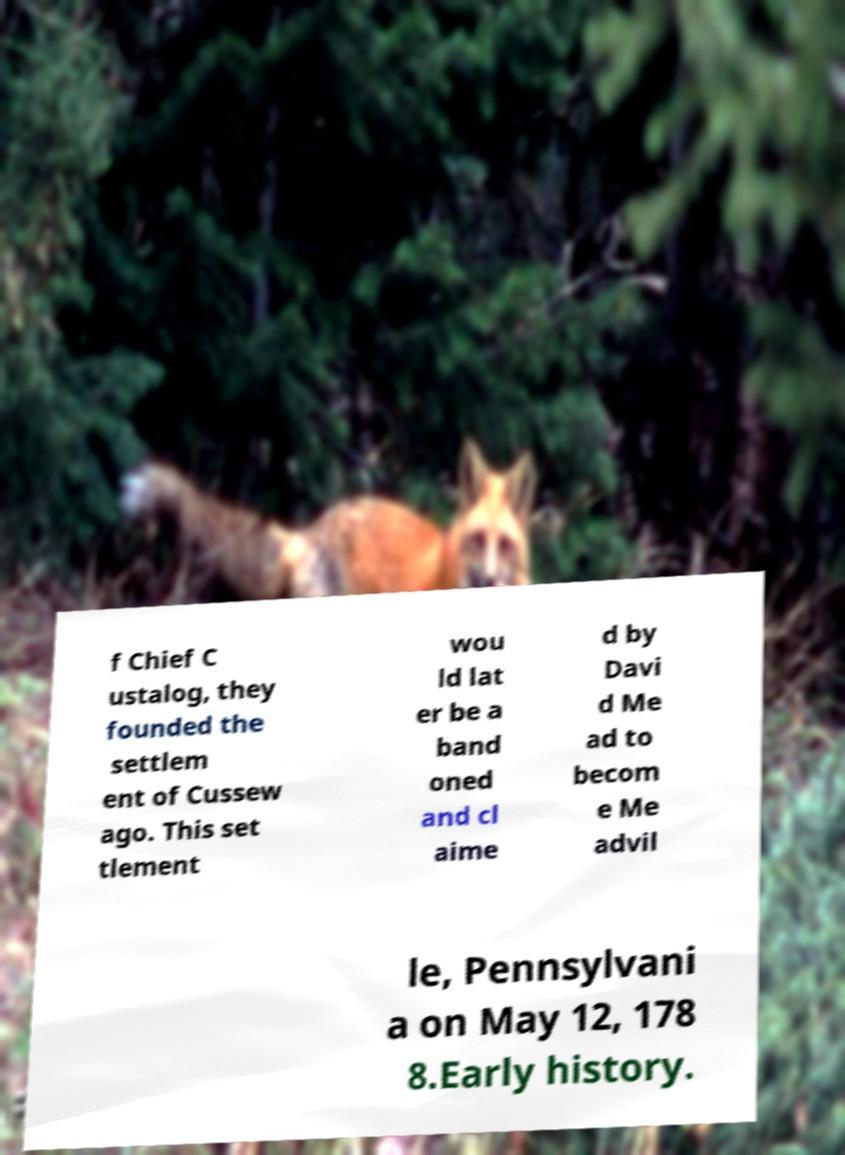Can you accurately transcribe the text from the provided image for me? f Chief C ustalog, they founded the settlem ent of Cussew ago. This set tlement wou ld lat er be a band oned and cl aime d by Davi d Me ad to becom e Me advil le, Pennsylvani a on May 12, 178 8.Early history. 